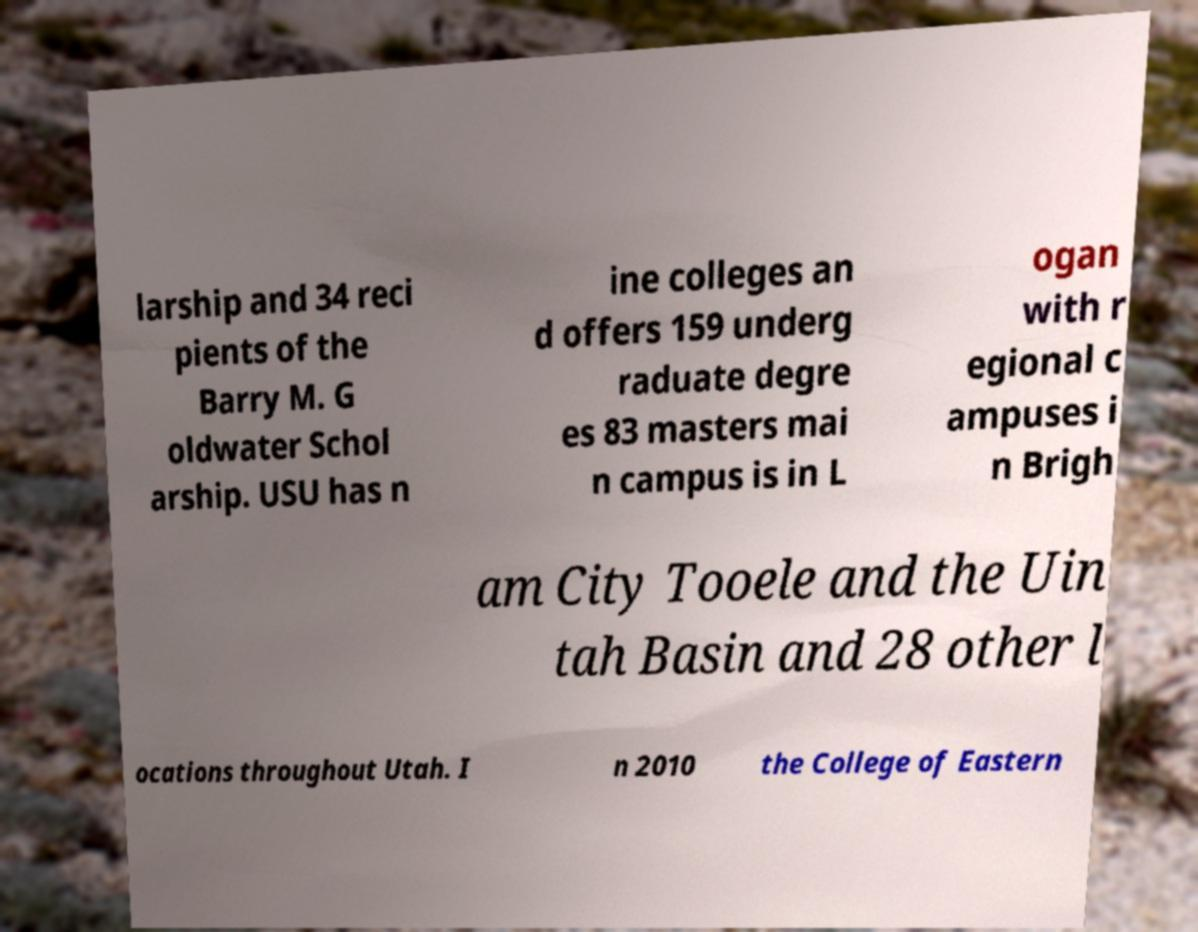What messages or text are displayed in this image? I need them in a readable, typed format. larship and 34 reci pients of the Barry M. G oldwater Schol arship. USU has n ine colleges an d offers 159 underg raduate degre es 83 masters mai n campus is in L ogan with r egional c ampuses i n Brigh am City Tooele and the Uin tah Basin and 28 other l ocations throughout Utah. I n 2010 the College of Eastern 